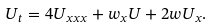Convert formula to latex. <formula><loc_0><loc_0><loc_500><loc_500>U _ { t } = 4 U _ { x x x } + w _ { x } U + 2 w U _ { x } .</formula> 